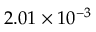Convert formula to latex. <formula><loc_0><loc_0><loc_500><loc_500>2 . 0 1 \times 1 0 ^ { - 3 }</formula> 